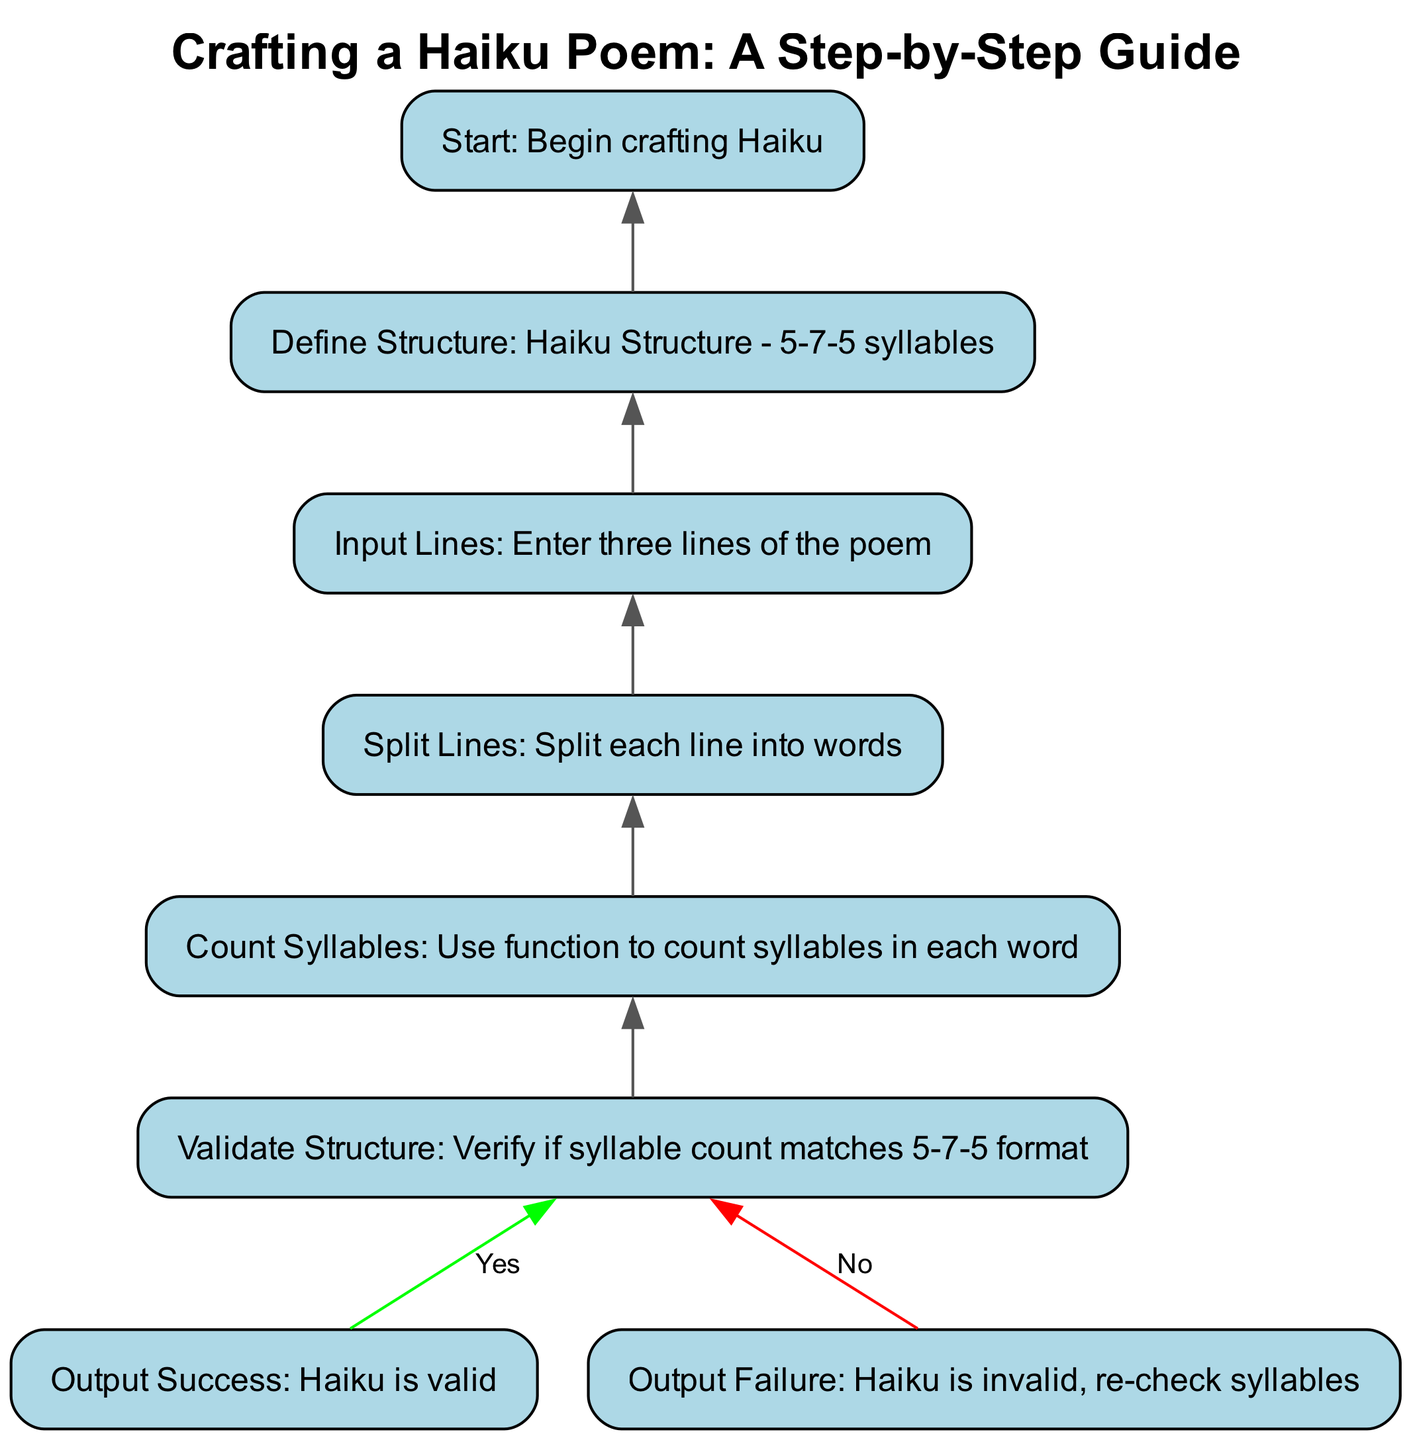What is the first step in crafting a haiku according to the diagram? The diagram indicates that the first step is to "Start: Begin crafting Haiku". This is the initial node that begins the haiku crafting process.
Answer: Start: Begin crafting Haiku How many lines should be entered when crafting a haiku? The diagram specifies "Input Lines: Enter three lines of the poem". This tells us the number of lines required for a haiku.
Answer: Three lines What structure does the haiku need to have? In the diagram, "Define Structure: Haiku Structure - 5-7-5 syllables" clearly states the required syllable structure for a haiku.
Answer: 5-7-5 syllables What happens if the syllable count does not match the required format? The diagram shows "Output Failure: Haiku is invalid, re-check syllables", indicating that if the syllable count does not match, the outcome is a failure message.
Answer: Haiku is invalid, re-check syllables What comes after counting syllables? According to the flowchart, after counting syllables ("Count Syllables: Use function to count syllables in each word"), the next step is "Validate Structure". This indicates a flow from counting to validation in the process.
Answer: Validate Structure What is the outcome if the syllable count is valid? The diagram indicates that if the structure is validated successfully, the process leads to "Output Success: Haiku is valid". This defines the positive result of the validation check.
Answer: Haiku is valid How does one start the process of crafting a haiku? The first node indicates that one begins with "Start: Begin crafting Haiku," which is the initiation point for the entire process outlined in the flowchart.
Answer: Start: Begin crafting Haiku Which step involves splitting the lines of the poem? The diagram shows that the step titled "Split Lines: Split each line into words" is where the lines are divided into individual words for further processing.
Answer: Split Lines What must be done after entering the lines of the poem? The diagram indicates that after entering the lines, one must proceed to "Split Lines", creating a necessary order of operations for the haiku crafting process.
Answer: Split Lines 